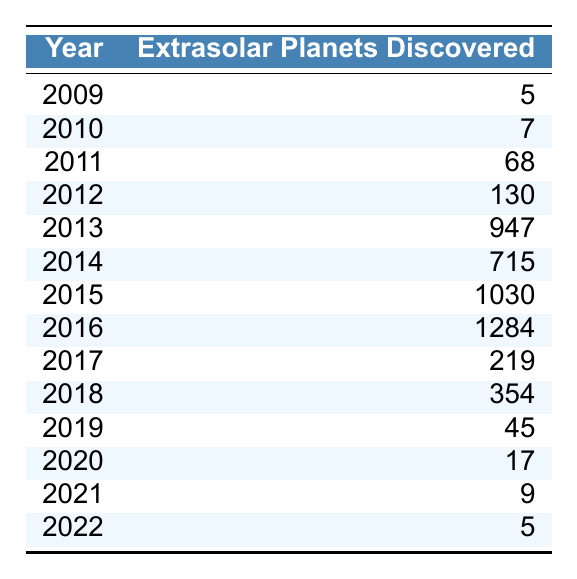What year had the highest number of extrasolar planets discovered? By examining the "Extrasolar Planets Discovered" column, it is evident that the year 2016 had the highest number of discoveries with 1284 planets.
Answer: 2016 How many extrasolar planets were discovered in 2015? The table shows that in 2015, there were 1030 extrasolar planets discovered.
Answer: 1030 What is the total number of extrasolar planets discovered from 2009 to 2022? To find the total, we sum the values in the "Extrasolar Planets Discovered" column: 5 + 7 + 68 + 130 + 947 + 715 + 1030 + 1284 + 219 + 354 + 45 + 17 + 9 + 5 = 3650.
Answer: 3650 Which year saw a significant drop in the number of discoveries right after 2016? After the peak in 2016, there was a noticeable decrease in discoveries in 2017, where the count dropped to 219.
Answer: 2017 Was there a year when fewer than 10 extrasolar planets were discovered? Yes, in the years 2021 (9) and 2022 (5), fewer than 10 planets were discovered.
Answer: Yes What is the difference in the number of extrasolar planets discovered between 2013 and 2014? The number of planets discovered in 2013 was 947, and in 2014 it was 715. The difference is 947 - 715 = 232.
Answer: 232 What was the average number of extrasolar planets discovered per year from 2010 to 2015? The total from 2010 to 2015 is 7 + 68 + 130 + 947 + 715 + 1030 = 1897. Since there are 6 years, the average is 1897 / 6 ≈ 316.17.
Answer: Approximately 316 Which year showed an increase compared to the previous year, immediately after 2014? From 2014 (715) to 2015 (1030), there was an increase.
Answer: Yes, in 2015 How many years had fewer than 100 discoveries? The years with fewer than 100 discoveries are 2009 (5), 2010 (7), 2011 (68), 2017 (219), 2018 (354), 2019 (45), 2020 (17), 2021 (9), and 2022 (5), making a total of 5 years (2009, 2010, 2011, 2019, 2021, 2022).
Answer: 5 years Was the number of discoveries in 2018 more than in 2019? The data shows that 2018 had 354 discoveries and 2019 had 45, confirming that 2018 had more discoveries.
Answer: Yes 